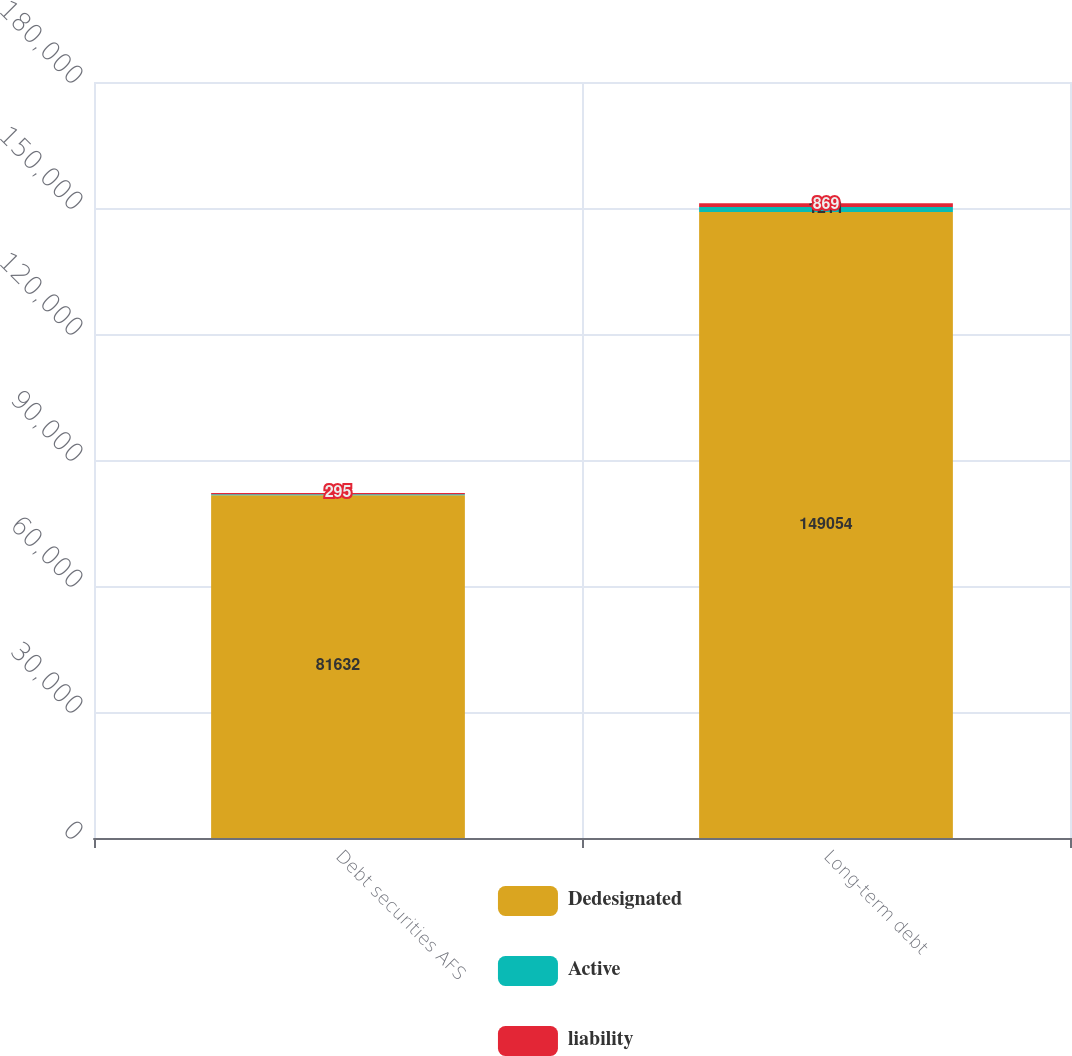<chart> <loc_0><loc_0><loc_500><loc_500><stacked_bar_chart><ecel><fcel>Debt securities AFS<fcel>Long-term debt<nl><fcel>Dedesignated<fcel>81632<fcel>149054<nl><fcel>Active<fcel>196<fcel>1211<nl><fcel>liability<fcel>295<fcel>869<nl></chart> 